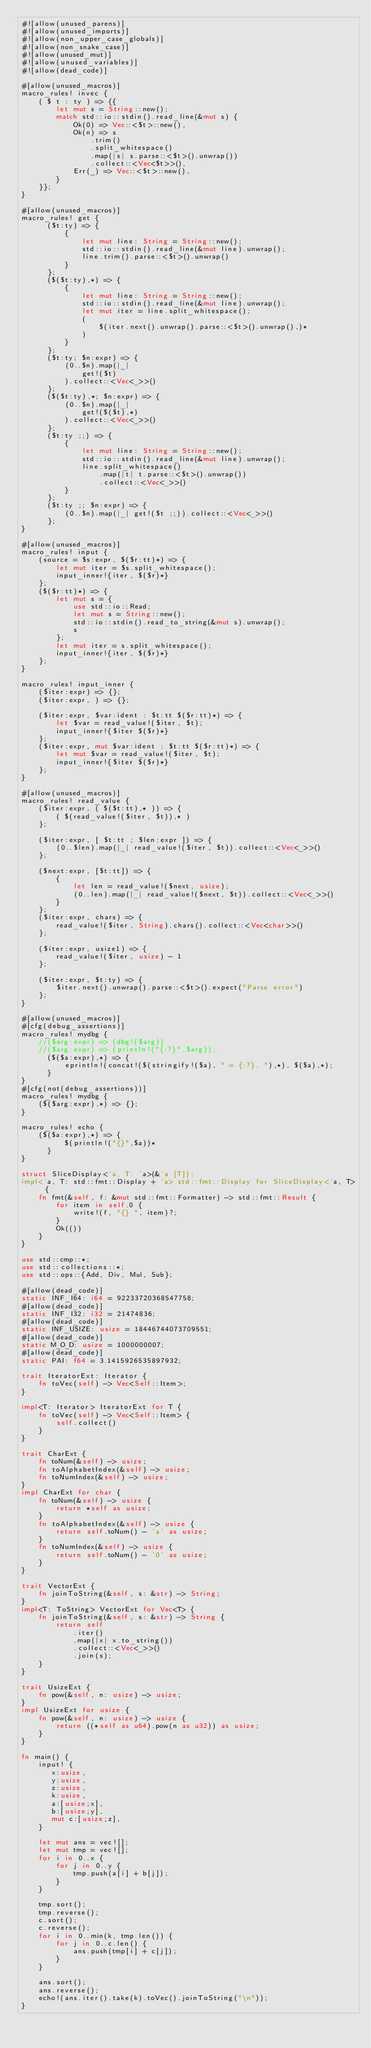<code> <loc_0><loc_0><loc_500><loc_500><_Rust_>#![allow(unused_parens)]
#![allow(unused_imports)]
#![allow(non_upper_case_globals)]
#![allow(non_snake_case)]
#![allow(unused_mut)]
#![allow(unused_variables)]
#![allow(dead_code)]

#[allow(unused_macros)]
macro_rules! invec {
    ( $ t : ty ) => {{
        let mut s = String::new();
        match std::io::stdin().read_line(&mut s) {
            Ok(0) => Vec::<$t>::new(),
            Ok(n) => s
                .trim()
                .split_whitespace()
                .map(|s| s.parse::<$t>().unwrap())
                .collect::<Vec<$t>>(),
            Err(_) => Vec::<$t>::new(),
        }
    }};
}

#[allow(unused_macros)]
macro_rules! get {
      ($t:ty) => {
          {
              let mut line: String = String::new();
              std::io::stdin().read_line(&mut line).unwrap();
              line.trim().parse::<$t>().unwrap()
          }
      };
      ($($t:ty),*) => {
          {
              let mut line: String = String::new();
              std::io::stdin().read_line(&mut line).unwrap();
              let mut iter = line.split_whitespace();
              (
                  $(iter.next().unwrap().parse::<$t>().unwrap(),)*
              )
          }
      };
      ($t:ty; $n:expr) => {
          (0..$n).map(|_|
              get!($t)
          ).collect::<Vec<_>>()
      };
      ($($t:ty),*; $n:expr) => {
          (0..$n).map(|_|
              get!($($t),*)
          ).collect::<Vec<_>>()
      };
      ($t:ty ;;) => {
          {
              let mut line: String = String::new();
              std::io::stdin().read_line(&mut line).unwrap();
              line.split_whitespace()
                  .map(|t| t.parse::<$t>().unwrap())
                  .collect::<Vec<_>>()
          }
      };
      ($t:ty ;; $n:expr) => {
          (0..$n).map(|_| get!($t ;;)).collect::<Vec<_>>()
      };
}

#[allow(unused_macros)]
macro_rules! input {
    (source = $s:expr, $($r:tt)*) => {
        let mut iter = $s.split_whitespace();
        input_inner!{iter, $($r)*}
    };
    ($($r:tt)*) => {
        let mut s = {
            use std::io::Read;
            let mut s = String::new();
            std::io::stdin().read_to_string(&mut s).unwrap();
            s
        };
        let mut iter = s.split_whitespace();
        input_inner!{iter, $($r)*}
    };
}

macro_rules! input_inner {
    ($iter:expr) => {};
    ($iter:expr, ) => {};

    ($iter:expr, $var:ident : $t:tt $($r:tt)*) => {
        let $var = read_value!($iter, $t);
        input_inner!{$iter $($r)*}
    };
    ($iter:expr, mut $var:ident : $t:tt $($r:tt)*) => {
        let mut $var = read_value!($iter, $t);
        input_inner!{$iter $($r)*}
    };
}

#[allow(unused_macros)]
macro_rules! read_value {
    ($iter:expr, ( $($t:tt),* )) => {
        ( $(read_value!($iter, $t)),* )
    };

    ($iter:expr, [ $t:tt ; $len:expr ]) => {
        (0..$len).map(|_| read_value!($iter, $t)).collect::<Vec<_>>()
    };

    ($next:expr, [$t:tt]) => {
        {
            let len = read_value!($next, usize);
            (0..len).map(|_| read_value!($next, $t)).collect::<Vec<_>>()
        }
    };
    ($iter:expr, chars) => {
        read_value!($iter, String).chars().collect::<Vec<char>>()
    };

    ($iter:expr, usize1) => {
        read_value!($iter, usize) - 1
    };

    ($iter:expr, $t:ty) => {
        $iter.next().unwrap().parse::<$t>().expect("Parse error")
    };
}

#[allow(unused_macros)]
#[cfg(debug_assertions)]
macro_rules! mydbg {
    //($arg:expr) => (dbg!($arg))
    //($arg:expr) => (println!("{:?}",$arg));
      ($($a:expr),*) => {
          eprintln!(concat!($(stringify!($a), " = {:?}, "),*), $($a),*);
      }
}
#[cfg(not(debug_assertions))]
macro_rules! mydbg {
    ($($arg:expr),*) => {};
}

macro_rules! echo {
    ($($a:expr),*) => {
          $(println!("{}",$a))*
      }
}

struct SliceDisplay<'a, T: 'a>(&'a [T]);
impl<'a, T: std::fmt::Display + 'a> std::fmt::Display for SliceDisplay<'a, T> {
    fn fmt(&self, f: &mut std::fmt::Formatter) -> std::fmt::Result {
        for item in self.0 {
            write!(f, "{} ", item)?;
        }
        Ok(())
    }
}

use std::cmp::*;
use std::collections::*;
use std::ops::{Add, Div, Mul, Sub};

#[allow(dead_code)]
static INF_I64: i64 = 92233720368547758;
#[allow(dead_code)]
static INF_I32: i32 = 21474836;
#[allow(dead_code)]
static INF_USIZE: usize = 18446744073709551;
#[allow(dead_code)]
static M_O_D: usize = 1000000007;
#[allow(dead_code)]
static PAI: f64 = 3.1415926535897932;

trait IteratorExt: Iterator {
    fn toVec(self) -> Vec<Self::Item>;
}

impl<T: Iterator> IteratorExt for T {
    fn toVec(self) -> Vec<Self::Item> {
        self.collect()
    }
}

trait CharExt {
    fn toNum(&self) -> usize;
    fn toAlphabetIndex(&self) -> usize;
    fn toNumIndex(&self) -> usize;
}
impl CharExt for char {
    fn toNum(&self) -> usize {
        return *self as usize;
    }
    fn toAlphabetIndex(&self) -> usize {
        return self.toNum() - 'a' as usize;
    }
    fn toNumIndex(&self) -> usize {
        return self.toNum() - '0' as usize;
    }
}

trait VectorExt {
    fn joinToString(&self, s: &str) -> String;
}
impl<T: ToString> VectorExt for Vec<T> {
    fn joinToString(&self, s: &str) -> String {
        return self
            .iter()
            .map(|x| x.to_string())
            .collect::<Vec<_>>()
            .join(s);
    }
}

trait UsizeExt {
    fn pow(&self, n: usize) -> usize;
}
impl UsizeExt for usize {
    fn pow(&self, n: usize) -> usize {
        return ((*self as u64).pow(n as u32)) as usize;
    }
}

fn main() {
    input! {
       x:usize,
       y:usize,
       z:usize,
       k:usize,
       a:[usize;x],
       b:[usize;y],
       mut c:[usize;z],
    }

    let mut ans = vec![];
    let mut tmp = vec![];
    for i in 0..x {
        for j in 0..y {
            tmp.push(a[i] + b[j]);
        }
    }

    tmp.sort();
    tmp.reverse();
    c.sort();
    c.reverse();
    for i in 0..min(k, tmp.len()) {
        for j in 0..c.len() {
            ans.push(tmp[i] + c[j]);
        }
    }

    ans.sort();
    ans.reverse();
    echo!(ans.iter().take(k).toVec().joinToString("\n"));
}
</code> 